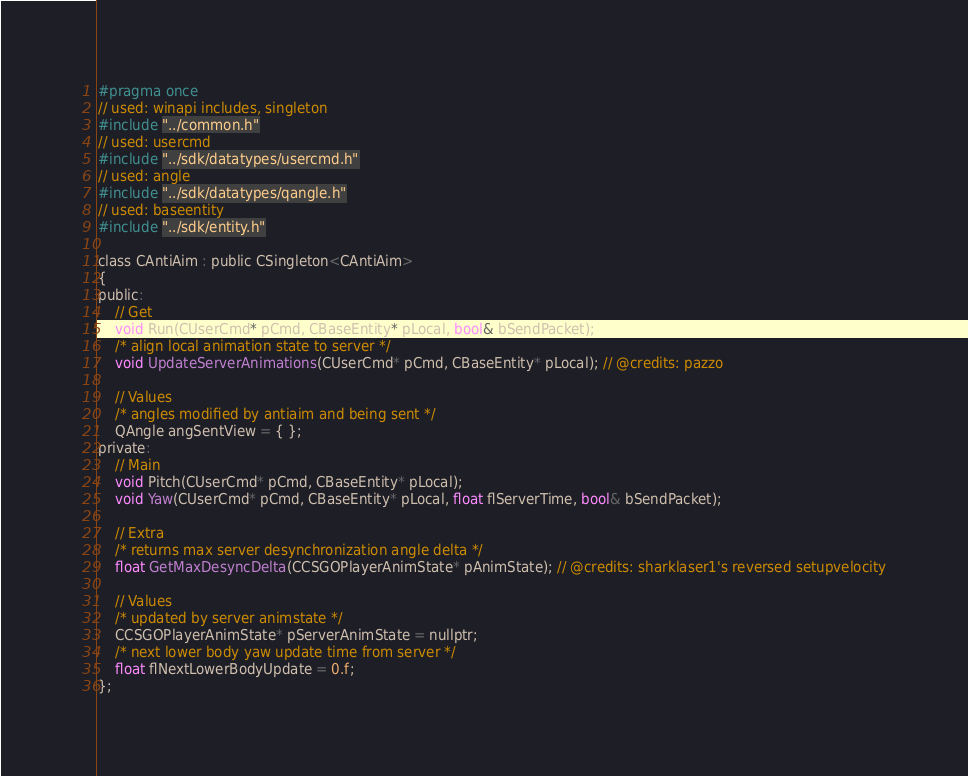<code> <loc_0><loc_0><loc_500><loc_500><_C_>#pragma once
// used: winapi includes, singleton
#include "../common.h"
// used: usercmd
#include "../sdk/datatypes/usercmd.h"
// used: angle
#include "../sdk/datatypes/qangle.h"
// used: baseentity
#include "../sdk/entity.h"

class CAntiAim : public CSingleton<CAntiAim>
{
public:
	// Get
	void Run(CUserCmd* pCmd, CBaseEntity* pLocal, bool& bSendPacket);
	/* align local animation state to server */
	void UpdateServerAnimations(CUserCmd* pCmd, CBaseEntity* pLocal); // @credits: pazzo

	// Values
	/* angles modified by antiaim and being sent */
	QAngle angSentView = { };
private:
	// Main
	void Pitch(CUserCmd* pCmd, CBaseEntity* pLocal);
	void Yaw(CUserCmd* pCmd, CBaseEntity* pLocal, float flServerTime, bool& bSendPacket);

	// Extra
	/* returns max server desynchronization angle delta */
	float GetMaxDesyncDelta(CCSGOPlayerAnimState* pAnimState); // @credits: sharklaser1's reversed setupvelocity

	// Values
	/* updated by server animstate */
	CCSGOPlayerAnimState* pServerAnimState = nullptr;
	/* next lower body yaw update time from server */
	float flNextLowerBodyUpdate = 0.f;
};
</code> 